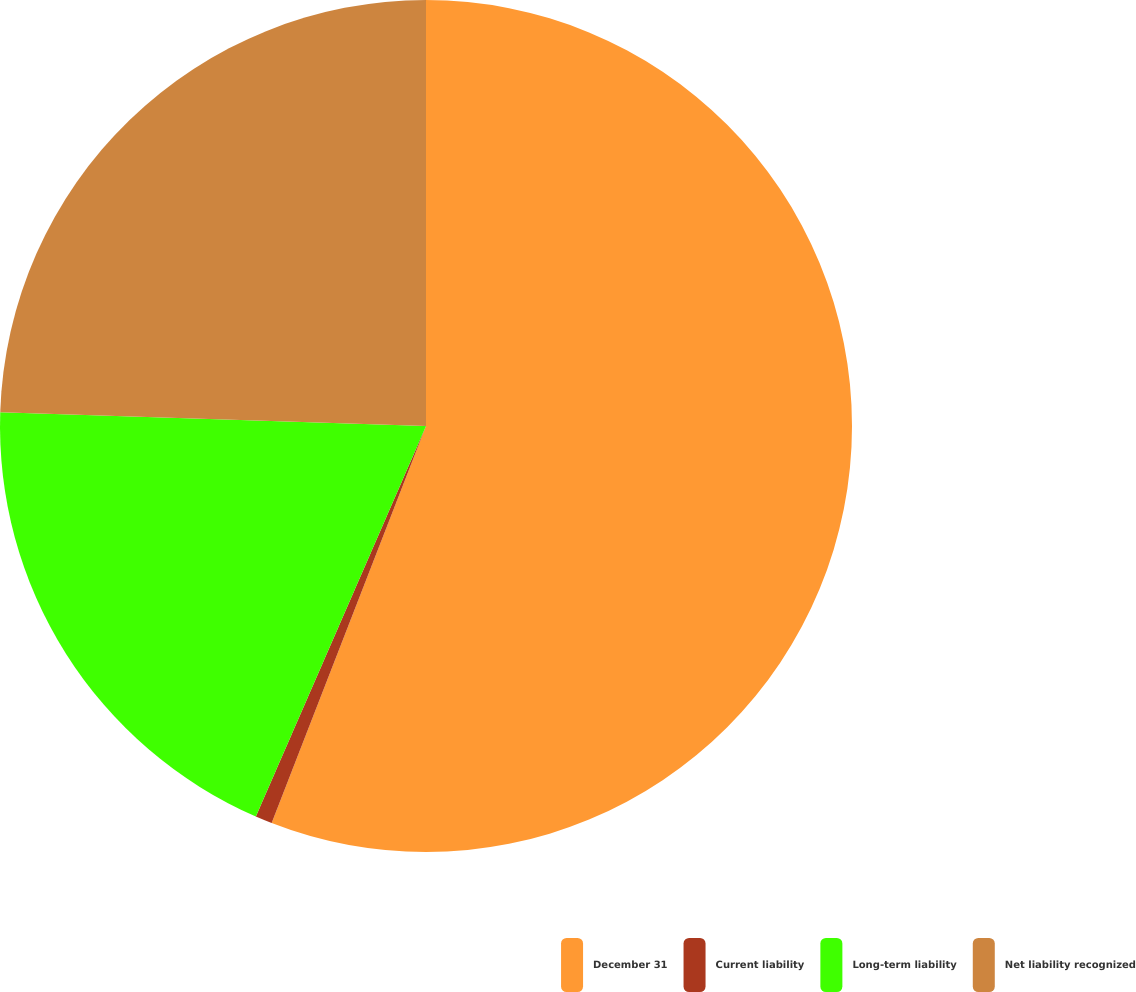Convert chart. <chart><loc_0><loc_0><loc_500><loc_500><pie_chart><fcel>December 31<fcel>Current liability<fcel>Long-term liability<fcel>Net liability recognized<nl><fcel>55.9%<fcel>0.64%<fcel>18.97%<fcel>24.49%<nl></chart> 